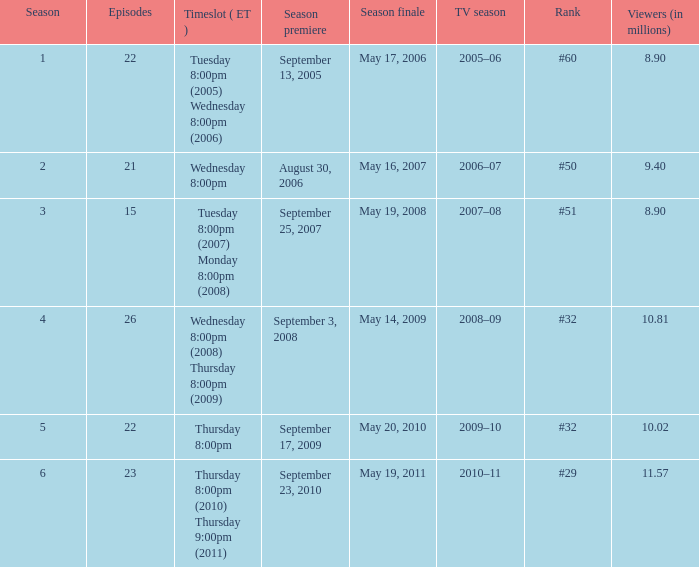When did the season finale gather an audience of 1 May 20, 2010. 